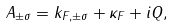Convert formula to latex. <formula><loc_0><loc_0><loc_500><loc_500>A _ { \pm \sigma } = k _ { F , \pm \sigma } + \kappa _ { F } + i Q ,</formula> 